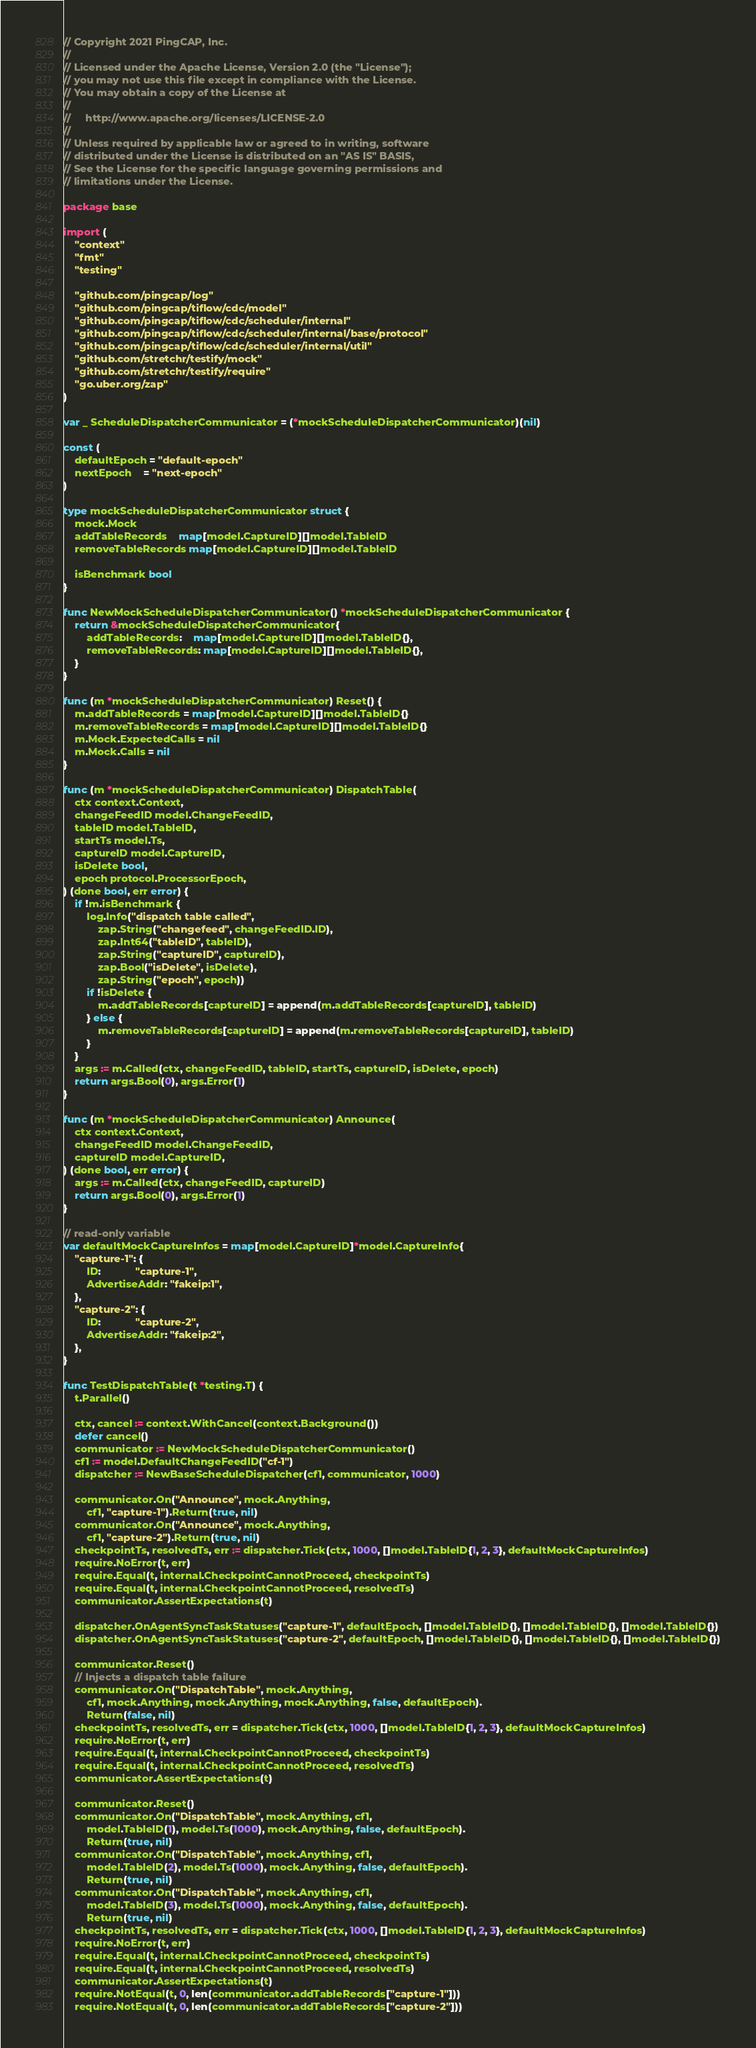<code> <loc_0><loc_0><loc_500><loc_500><_Go_>// Copyright 2021 PingCAP, Inc.
//
// Licensed under the Apache License, Version 2.0 (the "License");
// you may not use this file except in compliance with the License.
// You may obtain a copy of the License at
//
//     http://www.apache.org/licenses/LICENSE-2.0
//
// Unless required by applicable law or agreed to in writing, software
// distributed under the License is distributed on an "AS IS" BASIS,
// See the License for the specific language governing permissions and
// limitations under the License.

package base

import (
	"context"
	"fmt"
	"testing"

	"github.com/pingcap/log"
	"github.com/pingcap/tiflow/cdc/model"
	"github.com/pingcap/tiflow/cdc/scheduler/internal"
	"github.com/pingcap/tiflow/cdc/scheduler/internal/base/protocol"
	"github.com/pingcap/tiflow/cdc/scheduler/internal/util"
	"github.com/stretchr/testify/mock"
	"github.com/stretchr/testify/require"
	"go.uber.org/zap"
)

var _ ScheduleDispatcherCommunicator = (*mockScheduleDispatcherCommunicator)(nil)

const (
	defaultEpoch = "default-epoch"
	nextEpoch    = "next-epoch"
)

type mockScheduleDispatcherCommunicator struct {
	mock.Mock
	addTableRecords    map[model.CaptureID][]model.TableID
	removeTableRecords map[model.CaptureID][]model.TableID

	isBenchmark bool
}

func NewMockScheduleDispatcherCommunicator() *mockScheduleDispatcherCommunicator {
	return &mockScheduleDispatcherCommunicator{
		addTableRecords:    map[model.CaptureID][]model.TableID{},
		removeTableRecords: map[model.CaptureID][]model.TableID{},
	}
}

func (m *mockScheduleDispatcherCommunicator) Reset() {
	m.addTableRecords = map[model.CaptureID][]model.TableID{}
	m.removeTableRecords = map[model.CaptureID][]model.TableID{}
	m.Mock.ExpectedCalls = nil
	m.Mock.Calls = nil
}

func (m *mockScheduleDispatcherCommunicator) DispatchTable(
	ctx context.Context,
	changeFeedID model.ChangeFeedID,
	tableID model.TableID,
	startTs model.Ts,
	captureID model.CaptureID,
	isDelete bool,
	epoch protocol.ProcessorEpoch,
) (done bool, err error) {
	if !m.isBenchmark {
		log.Info("dispatch table called",
			zap.String("changefeed", changeFeedID.ID),
			zap.Int64("tableID", tableID),
			zap.String("captureID", captureID),
			zap.Bool("isDelete", isDelete),
			zap.String("epoch", epoch))
		if !isDelete {
			m.addTableRecords[captureID] = append(m.addTableRecords[captureID], tableID)
		} else {
			m.removeTableRecords[captureID] = append(m.removeTableRecords[captureID], tableID)
		}
	}
	args := m.Called(ctx, changeFeedID, tableID, startTs, captureID, isDelete, epoch)
	return args.Bool(0), args.Error(1)
}

func (m *mockScheduleDispatcherCommunicator) Announce(
	ctx context.Context,
	changeFeedID model.ChangeFeedID,
	captureID model.CaptureID,
) (done bool, err error) {
	args := m.Called(ctx, changeFeedID, captureID)
	return args.Bool(0), args.Error(1)
}

// read-only variable
var defaultMockCaptureInfos = map[model.CaptureID]*model.CaptureInfo{
	"capture-1": {
		ID:            "capture-1",
		AdvertiseAddr: "fakeip:1",
	},
	"capture-2": {
		ID:            "capture-2",
		AdvertiseAddr: "fakeip:2",
	},
}

func TestDispatchTable(t *testing.T) {
	t.Parallel()

	ctx, cancel := context.WithCancel(context.Background())
	defer cancel()
	communicator := NewMockScheduleDispatcherCommunicator()
	cf1 := model.DefaultChangeFeedID("cf-1")
	dispatcher := NewBaseScheduleDispatcher(cf1, communicator, 1000)

	communicator.On("Announce", mock.Anything,
		cf1, "capture-1").Return(true, nil)
	communicator.On("Announce", mock.Anything,
		cf1, "capture-2").Return(true, nil)
	checkpointTs, resolvedTs, err := dispatcher.Tick(ctx, 1000, []model.TableID{1, 2, 3}, defaultMockCaptureInfos)
	require.NoError(t, err)
	require.Equal(t, internal.CheckpointCannotProceed, checkpointTs)
	require.Equal(t, internal.CheckpointCannotProceed, resolvedTs)
	communicator.AssertExpectations(t)

	dispatcher.OnAgentSyncTaskStatuses("capture-1", defaultEpoch, []model.TableID{}, []model.TableID{}, []model.TableID{})
	dispatcher.OnAgentSyncTaskStatuses("capture-2", defaultEpoch, []model.TableID{}, []model.TableID{}, []model.TableID{})

	communicator.Reset()
	// Injects a dispatch table failure
	communicator.On("DispatchTable", mock.Anything,
		cf1, mock.Anything, mock.Anything, mock.Anything, false, defaultEpoch).
		Return(false, nil)
	checkpointTs, resolvedTs, err = dispatcher.Tick(ctx, 1000, []model.TableID{1, 2, 3}, defaultMockCaptureInfos)
	require.NoError(t, err)
	require.Equal(t, internal.CheckpointCannotProceed, checkpointTs)
	require.Equal(t, internal.CheckpointCannotProceed, resolvedTs)
	communicator.AssertExpectations(t)

	communicator.Reset()
	communicator.On("DispatchTable", mock.Anything, cf1,
		model.TableID(1), model.Ts(1000), mock.Anything, false, defaultEpoch).
		Return(true, nil)
	communicator.On("DispatchTable", mock.Anything, cf1,
		model.TableID(2), model.Ts(1000), mock.Anything, false, defaultEpoch).
		Return(true, nil)
	communicator.On("DispatchTable", mock.Anything, cf1,
		model.TableID(3), model.Ts(1000), mock.Anything, false, defaultEpoch).
		Return(true, nil)
	checkpointTs, resolvedTs, err = dispatcher.Tick(ctx, 1000, []model.TableID{1, 2, 3}, defaultMockCaptureInfos)
	require.NoError(t, err)
	require.Equal(t, internal.CheckpointCannotProceed, checkpointTs)
	require.Equal(t, internal.CheckpointCannotProceed, resolvedTs)
	communicator.AssertExpectations(t)
	require.NotEqual(t, 0, len(communicator.addTableRecords["capture-1"]))
	require.NotEqual(t, 0, len(communicator.addTableRecords["capture-2"]))</code> 